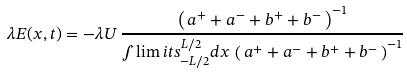Convert formula to latex. <formula><loc_0><loc_0><loc_500><loc_500>\lambda E ( x , t ) = - \lambda U \, \frac { \left ( \, a ^ { + } + a ^ { - } + b ^ { + } + b ^ { - } \, \right ) ^ { - 1 } } { \int \lim i t s _ { - L / 2 } ^ { L / 2 } d x \, \left ( \, a ^ { + } + a ^ { - } + b ^ { + } + b ^ { - } \, \right ) ^ { - 1 } }</formula> 